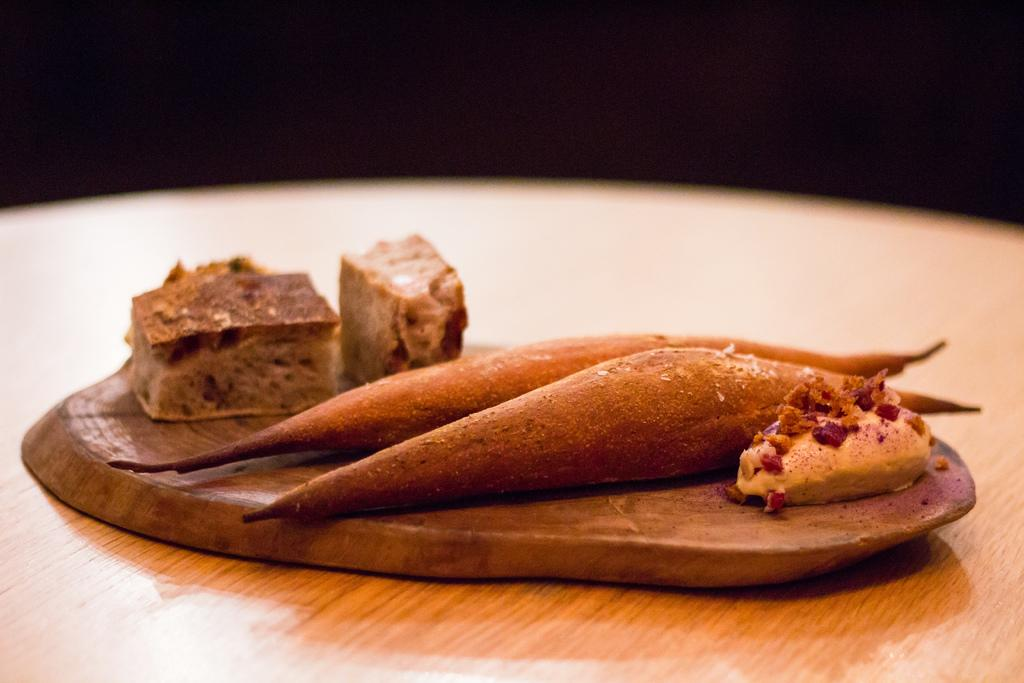What type of items can be seen in the image? There are food items in the image. What is the surface on which the food items are placed? The food items are on a wooden surface. What is the wooden surface resting on? The wooden surface is on a wooden table. What color is the background of the image? The background of the image is black. What type of plastic is covering the food items in the image? There is no plastic covering the food items in the image; they are on a wooden surface. 